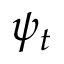Convert formula to latex. <formula><loc_0><loc_0><loc_500><loc_500>\psi _ { t }</formula> 